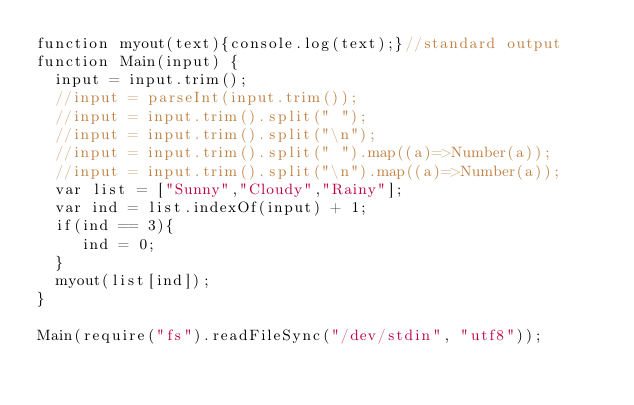Convert code to text. <code><loc_0><loc_0><loc_500><loc_500><_JavaScript_>function myout(text){console.log(text);}//standard output
function Main(input) {
	input = input.trim();
	//input = parseInt(input.trim());
	//input = input.trim().split(" ");
	//input = input.trim().split("\n");
	//input = input.trim().split(" ").map((a)=>Number(a));
	//input = input.trim().split("\n").map((a)=>Number(a));
  var list = ["Sunny","Cloudy","Rainy"];
  var ind = list.indexOf(input) + 1;
  if(ind == 3){
     ind = 0;
  }
  myout(list[ind]);
}

Main(require("fs").readFileSync("/dev/stdin", "utf8"));
</code> 